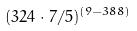<formula> <loc_0><loc_0><loc_500><loc_500>( 3 2 4 \cdot 7 / 5 ) ^ { ( 9 - 3 8 8 ) }</formula> 